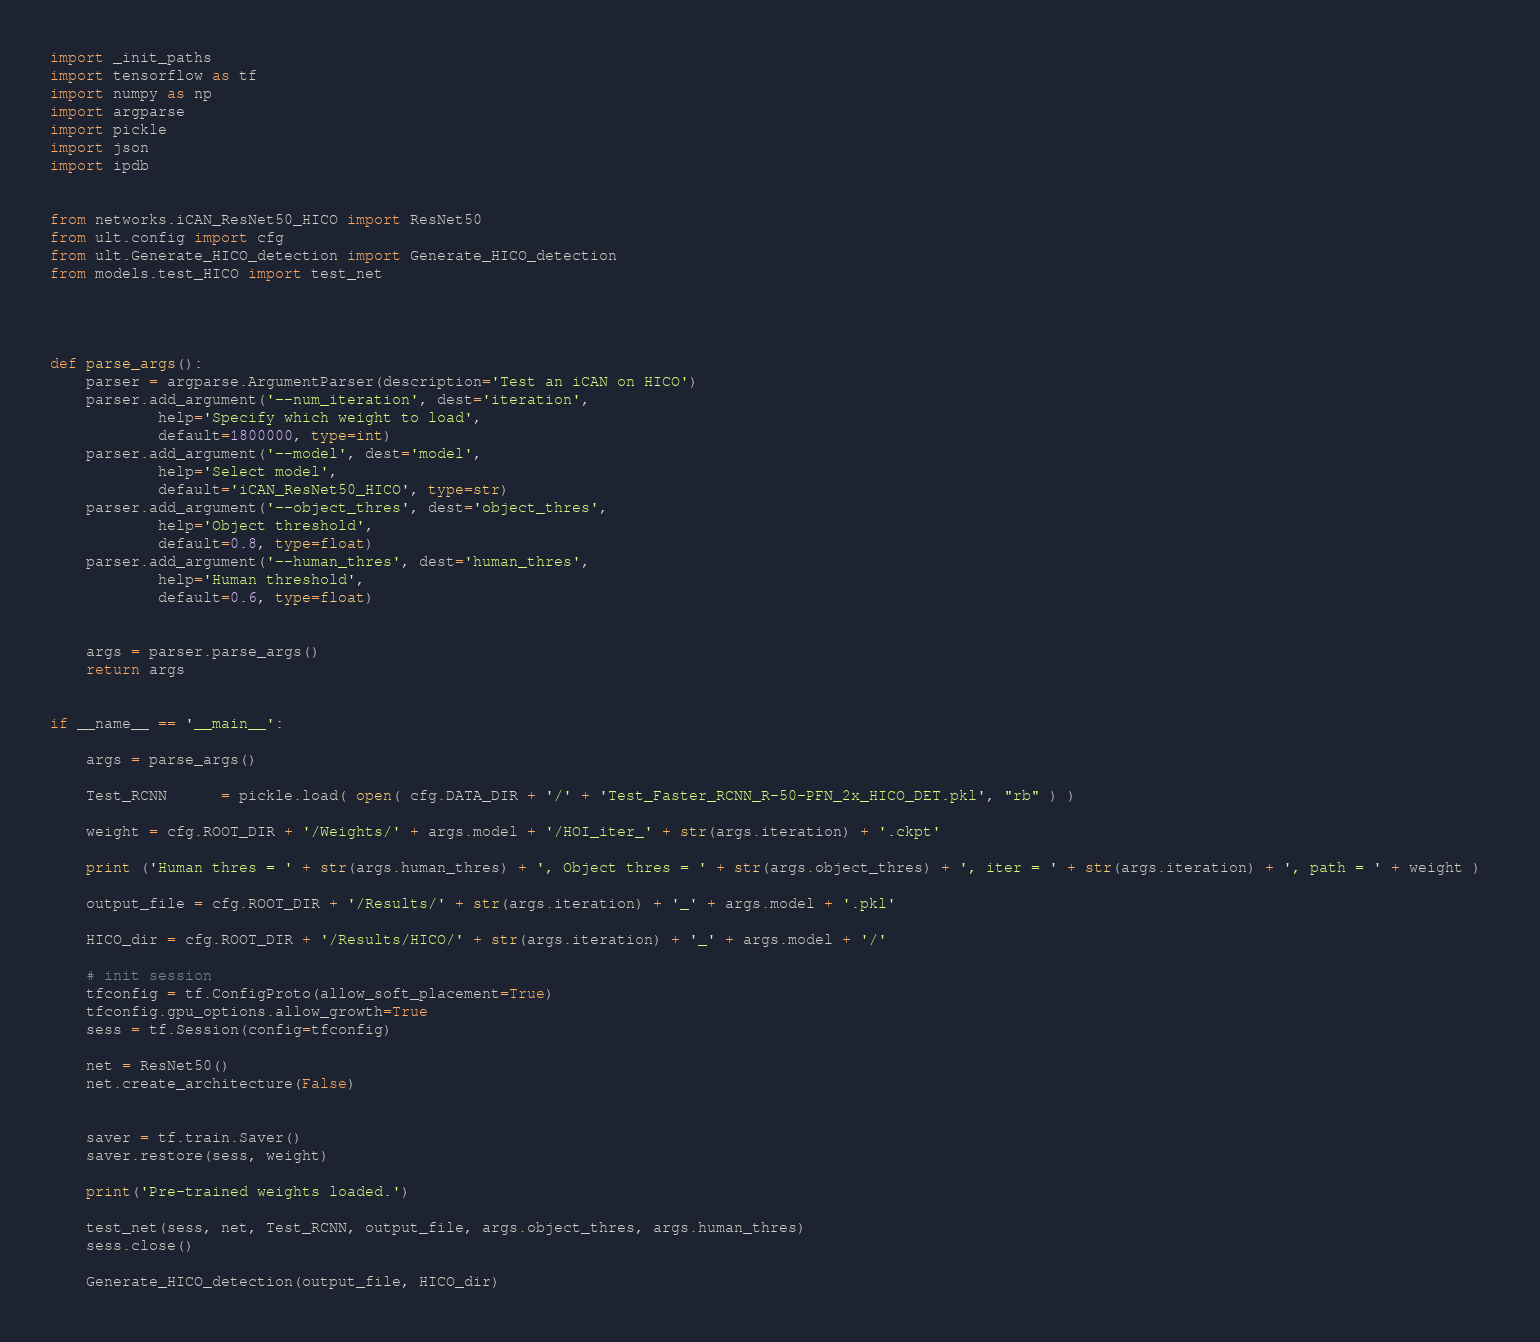<code> <loc_0><loc_0><loc_500><loc_500><_Python_>import _init_paths
import tensorflow as tf
import numpy as np
import argparse
import pickle
import json
import ipdb


from networks.iCAN_ResNet50_HICO import ResNet50
from ult.config import cfg
from ult.Generate_HICO_detection import Generate_HICO_detection
from models.test_HICO import test_net




def parse_args():
    parser = argparse.ArgumentParser(description='Test an iCAN on HICO')
    parser.add_argument('--num_iteration', dest='iteration',
            help='Specify which weight to load',
            default=1800000, type=int)
    parser.add_argument('--model', dest='model',
            help='Select model',
            default='iCAN_ResNet50_HICO', type=str)
    parser.add_argument('--object_thres', dest='object_thres',
            help='Object threshold',
            default=0.8, type=float)
    parser.add_argument('--human_thres', dest='human_thres',
            help='Human threshold',
            default=0.6, type=float)


    args = parser.parse_args()
    return args


if __name__ == '__main__':

    args = parse_args()

    Test_RCNN      = pickle.load( open( cfg.DATA_DIR + '/' + 'Test_Faster_RCNN_R-50-PFN_2x_HICO_DET.pkl', "rb" ) )
   
    weight = cfg.ROOT_DIR + '/Weights/' + args.model + '/HOI_iter_' + str(args.iteration) + '.ckpt'

    print ('Human thres = ' + str(args.human_thres) + ', Object thres = ' + str(args.object_thres) + ', iter = ' + str(args.iteration) + ', path = ' + weight ) 
  
    output_file = cfg.ROOT_DIR + '/Results/' + str(args.iteration) + '_' + args.model + '.pkl'

    HICO_dir = cfg.ROOT_DIR + '/Results/HICO/' + str(args.iteration) + '_' + args.model + '/'

    # init session
    tfconfig = tf.ConfigProto(allow_soft_placement=True)
    tfconfig.gpu_options.allow_growth=True
    sess = tf.Session(config=tfconfig)

    net = ResNet50()
    net.create_architecture(False)
    
    
    saver = tf.train.Saver()
    saver.restore(sess, weight)

    print('Pre-trained weights loaded.')
    
    test_net(sess, net, Test_RCNN, output_file, args.object_thres, args.human_thres)
    sess.close()

    Generate_HICO_detection(output_file, HICO_dir)
</code> 